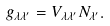Convert formula to latex. <formula><loc_0><loc_0><loc_500><loc_500>g _ { \lambda \lambda ^ { \prime } } = V _ { \lambda \lambda ^ { \prime } } N _ { \lambda ^ { \prime } } .</formula> 